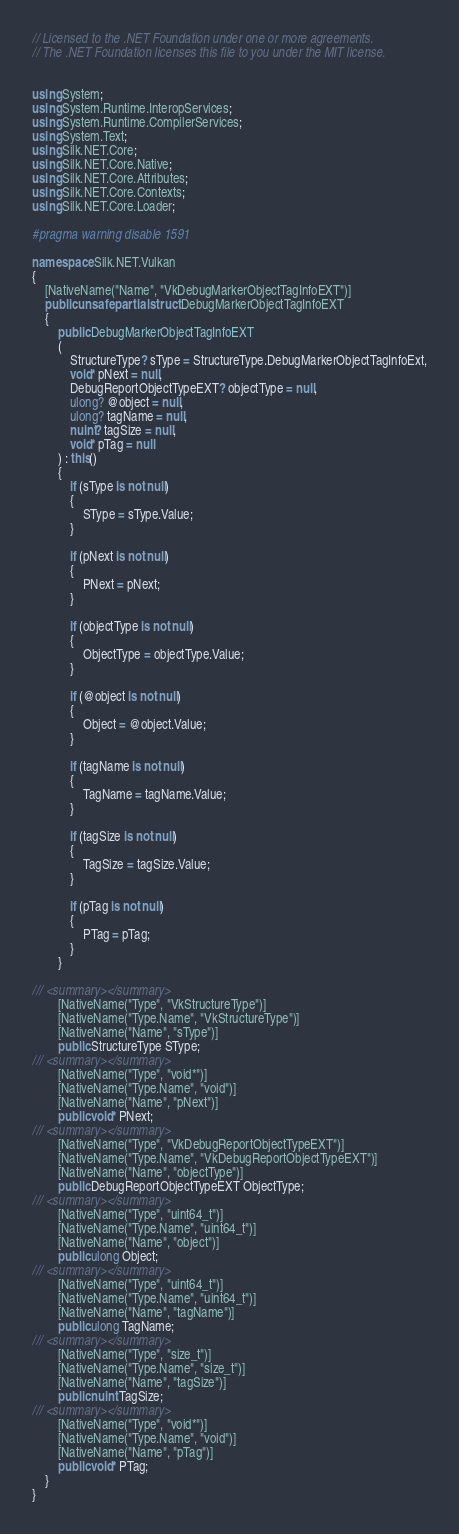<code> <loc_0><loc_0><loc_500><loc_500><_C#_>// Licensed to the .NET Foundation under one or more agreements.
// The .NET Foundation licenses this file to you under the MIT license.


using System;
using System.Runtime.InteropServices;
using System.Runtime.CompilerServices;
using System.Text;
using Silk.NET.Core;
using Silk.NET.Core.Native;
using Silk.NET.Core.Attributes;
using Silk.NET.Core.Contexts;
using Silk.NET.Core.Loader;

#pragma warning disable 1591

namespace Silk.NET.Vulkan
{
    [NativeName("Name", "VkDebugMarkerObjectTagInfoEXT")]
    public unsafe partial struct DebugMarkerObjectTagInfoEXT
    {
        public DebugMarkerObjectTagInfoEXT
        (
            StructureType? sType = StructureType.DebugMarkerObjectTagInfoExt,
            void* pNext = null,
            DebugReportObjectTypeEXT? objectType = null,
            ulong? @object = null,
            ulong? tagName = null,
            nuint? tagSize = null,
            void* pTag = null
        ) : this()
        {
            if (sType is not null)
            {
                SType = sType.Value;
            }

            if (pNext is not null)
            {
                PNext = pNext;
            }

            if (objectType is not null)
            {
                ObjectType = objectType.Value;
            }

            if (@object is not null)
            {
                Object = @object.Value;
            }

            if (tagName is not null)
            {
                TagName = tagName.Value;
            }

            if (tagSize is not null)
            {
                TagSize = tagSize.Value;
            }

            if (pTag is not null)
            {
                PTag = pTag;
            }
        }

/// <summary></summary>
        [NativeName("Type", "VkStructureType")]
        [NativeName("Type.Name", "VkStructureType")]
        [NativeName("Name", "sType")]
        public StructureType SType;
/// <summary></summary>
        [NativeName("Type", "void*")]
        [NativeName("Type.Name", "void")]
        [NativeName("Name", "pNext")]
        public void* PNext;
/// <summary></summary>
        [NativeName("Type", "VkDebugReportObjectTypeEXT")]
        [NativeName("Type.Name", "VkDebugReportObjectTypeEXT")]
        [NativeName("Name", "objectType")]
        public DebugReportObjectTypeEXT ObjectType;
/// <summary></summary>
        [NativeName("Type", "uint64_t")]
        [NativeName("Type.Name", "uint64_t")]
        [NativeName("Name", "object")]
        public ulong Object;
/// <summary></summary>
        [NativeName("Type", "uint64_t")]
        [NativeName("Type.Name", "uint64_t")]
        [NativeName("Name", "tagName")]
        public ulong TagName;
/// <summary></summary>
        [NativeName("Type", "size_t")]
        [NativeName("Type.Name", "size_t")]
        [NativeName("Name", "tagSize")]
        public nuint TagSize;
/// <summary></summary>
        [NativeName("Type", "void*")]
        [NativeName("Type.Name", "void")]
        [NativeName("Name", "pTag")]
        public void* PTag;
    }
}
</code> 